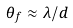<formula> <loc_0><loc_0><loc_500><loc_500>\theta _ { f } \approx \lambda / d</formula> 